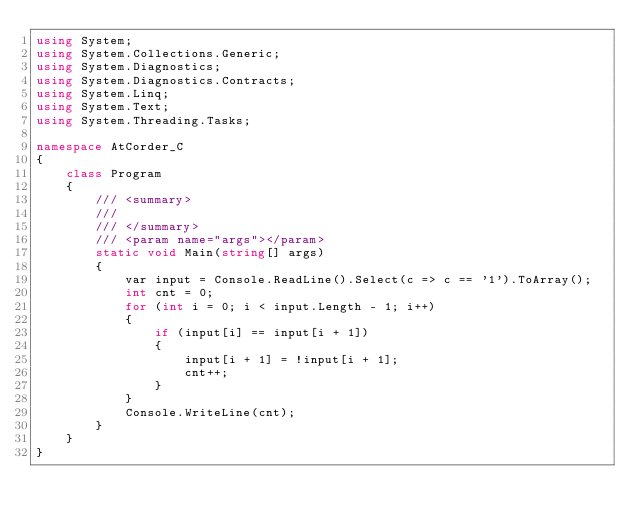<code> <loc_0><loc_0><loc_500><loc_500><_C#_>using System;
using System.Collections.Generic;
using System.Diagnostics;
using System.Diagnostics.Contracts;
using System.Linq;
using System.Text;
using System.Threading.Tasks;

namespace AtCorder_C
{
    class Program
    {
        /// <summary>
        /// 
        /// </summary>
        /// <param name="args"></param>
        static void Main(string[] args)
        {
            var input = Console.ReadLine().Select(c => c == '1').ToArray();
            int cnt = 0;
            for (int i = 0; i < input.Length - 1; i++)
            {
                if (input[i] == input[i + 1])
                {
                    input[i + 1] = !input[i + 1];
                    cnt++;
                }
            }
            Console.WriteLine(cnt);
        }
    }
}
</code> 